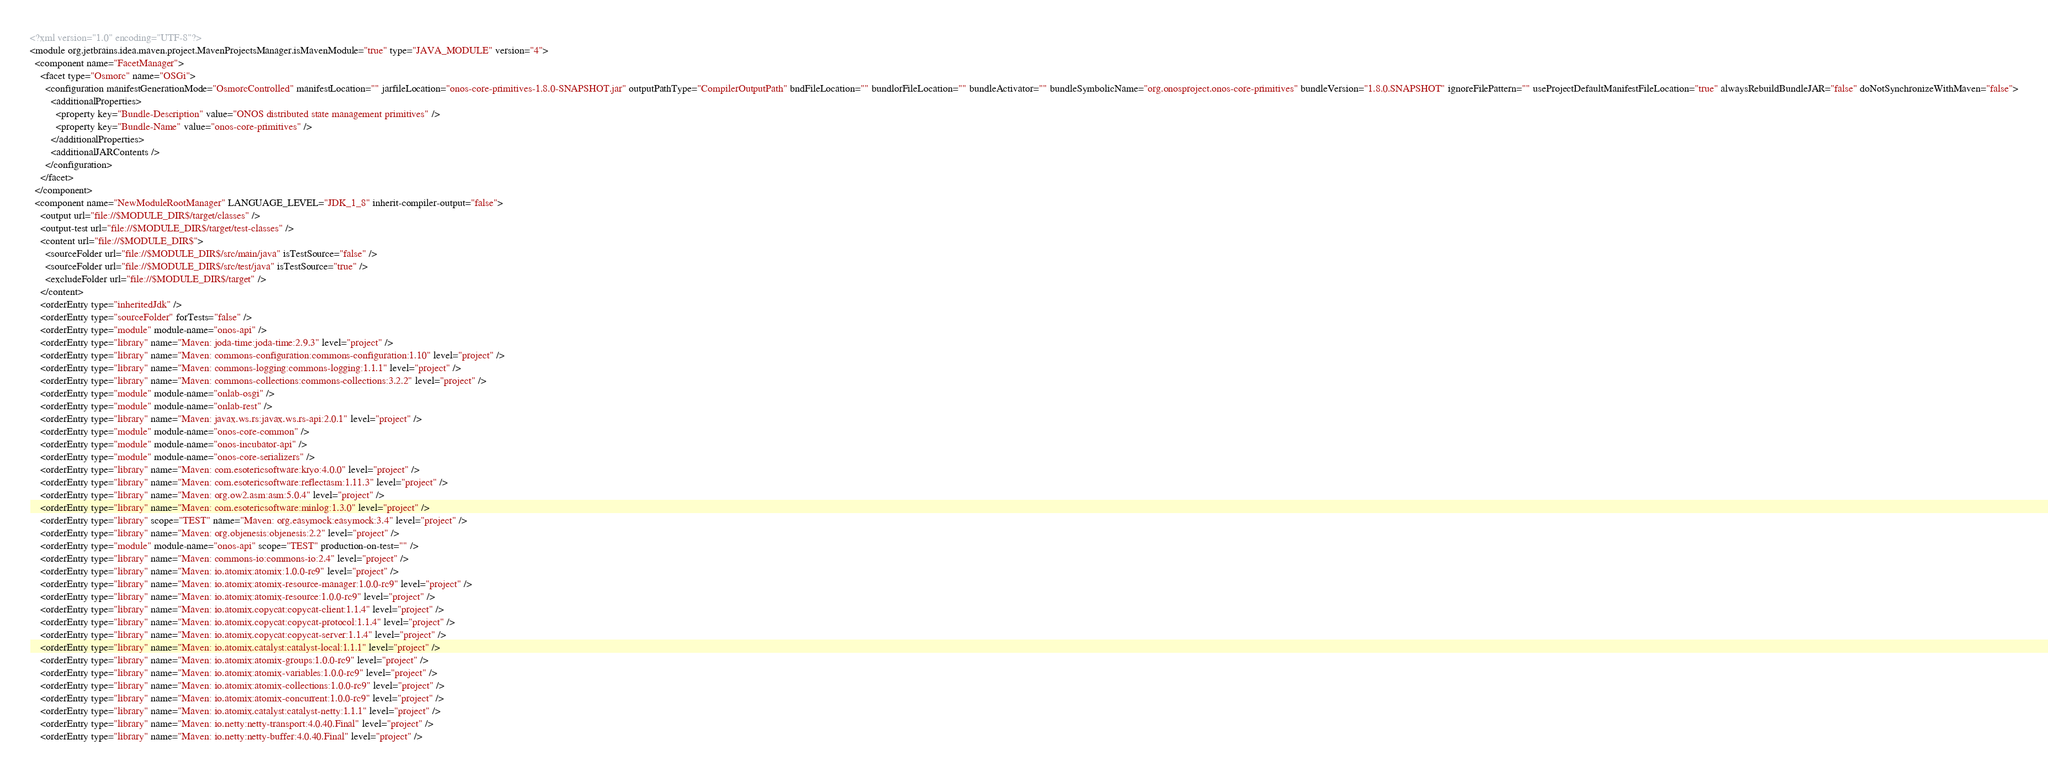Convert code to text. <code><loc_0><loc_0><loc_500><loc_500><_XML_><?xml version="1.0" encoding="UTF-8"?>
<module org.jetbrains.idea.maven.project.MavenProjectsManager.isMavenModule="true" type="JAVA_MODULE" version="4">
  <component name="FacetManager">
    <facet type="Osmorc" name="OSGi">
      <configuration manifestGenerationMode="OsmorcControlled" manifestLocation="" jarfileLocation="onos-core-primitives-1.8.0-SNAPSHOT.jar" outputPathType="CompilerOutputPath" bndFileLocation="" bundlorFileLocation="" bundleActivator="" bundleSymbolicName="org.onosproject.onos-core-primitives" bundleVersion="1.8.0.SNAPSHOT" ignoreFilePattern="" useProjectDefaultManifestFileLocation="true" alwaysRebuildBundleJAR="false" doNotSynchronizeWithMaven="false">
        <additionalProperties>
          <property key="Bundle-Description" value="ONOS distributed state management primitives" />
          <property key="Bundle-Name" value="onos-core-primitives" />
        </additionalProperties>
        <additionalJARContents />
      </configuration>
    </facet>
  </component>
  <component name="NewModuleRootManager" LANGUAGE_LEVEL="JDK_1_8" inherit-compiler-output="false">
    <output url="file://$MODULE_DIR$/target/classes" />
    <output-test url="file://$MODULE_DIR$/target/test-classes" />
    <content url="file://$MODULE_DIR$">
      <sourceFolder url="file://$MODULE_DIR$/src/main/java" isTestSource="false" />
      <sourceFolder url="file://$MODULE_DIR$/src/test/java" isTestSource="true" />
      <excludeFolder url="file://$MODULE_DIR$/target" />
    </content>
    <orderEntry type="inheritedJdk" />
    <orderEntry type="sourceFolder" forTests="false" />
    <orderEntry type="module" module-name="onos-api" />
    <orderEntry type="library" name="Maven: joda-time:joda-time:2.9.3" level="project" />
    <orderEntry type="library" name="Maven: commons-configuration:commons-configuration:1.10" level="project" />
    <orderEntry type="library" name="Maven: commons-logging:commons-logging:1.1.1" level="project" />
    <orderEntry type="library" name="Maven: commons-collections:commons-collections:3.2.2" level="project" />
    <orderEntry type="module" module-name="onlab-osgi" />
    <orderEntry type="module" module-name="onlab-rest" />
    <orderEntry type="library" name="Maven: javax.ws.rs:javax.ws.rs-api:2.0.1" level="project" />
    <orderEntry type="module" module-name="onos-core-common" />
    <orderEntry type="module" module-name="onos-incubator-api" />
    <orderEntry type="module" module-name="onos-core-serializers" />
    <orderEntry type="library" name="Maven: com.esotericsoftware:kryo:4.0.0" level="project" />
    <orderEntry type="library" name="Maven: com.esotericsoftware:reflectasm:1.11.3" level="project" />
    <orderEntry type="library" name="Maven: org.ow2.asm:asm:5.0.4" level="project" />
    <orderEntry type="library" name="Maven: com.esotericsoftware:minlog:1.3.0" level="project" />
    <orderEntry type="library" scope="TEST" name="Maven: org.easymock:easymock:3.4" level="project" />
    <orderEntry type="library" name="Maven: org.objenesis:objenesis:2.2" level="project" />
    <orderEntry type="module" module-name="onos-api" scope="TEST" production-on-test="" />
    <orderEntry type="library" name="Maven: commons-io:commons-io:2.4" level="project" />
    <orderEntry type="library" name="Maven: io.atomix:atomix:1.0.0-rc9" level="project" />
    <orderEntry type="library" name="Maven: io.atomix:atomix-resource-manager:1.0.0-rc9" level="project" />
    <orderEntry type="library" name="Maven: io.atomix:atomix-resource:1.0.0-rc9" level="project" />
    <orderEntry type="library" name="Maven: io.atomix.copycat:copycat-client:1.1.4" level="project" />
    <orderEntry type="library" name="Maven: io.atomix.copycat:copycat-protocol:1.1.4" level="project" />
    <orderEntry type="library" name="Maven: io.atomix.copycat:copycat-server:1.1.4" level="project" />
    <orderEntry type="library" name="Maven: io.atomix.catalyst:catalyst-local:1.1.1" level="project" />
    <orderEntry type="library" name="Maven: io.atomix:atomix-groups:1.0.0-rc9" level="project" />
    <orderEntry type="library" name="Maven: io.atomix:atomix-variables:1.0.0-rc9" level="project" />
    <orderEntry type="library" name="Maven: io.atomix:atomix-collections:1.0.0-rc9" level="project" />
    <orderEntry type="library" name="Maven: io.atomix:atomix-concurrent:1.0.0-rc9" level="project" />
    <orderEntry type="library" name="Maven: io.atomix.catalyst:catalyst-netty:1.1.1" level="project" />
    <orderEntry type="library" name="Maven: io.netty:netty-transport:4.0.40.Final" level="project" />
    <orderEntry type="library" name="Maven: io.netty:netty-buffer:4.0.40.Final" level="project" /></code> 